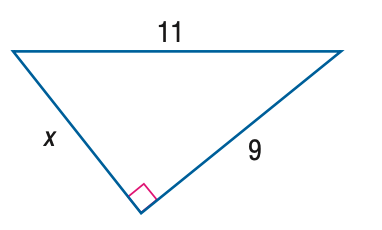Question: Find x.
Choices:
A. 5
B. 2 \sqrt { 10 }
C. 7
D. \sqrt { 202 }
Answer with the letter. Answer: B 